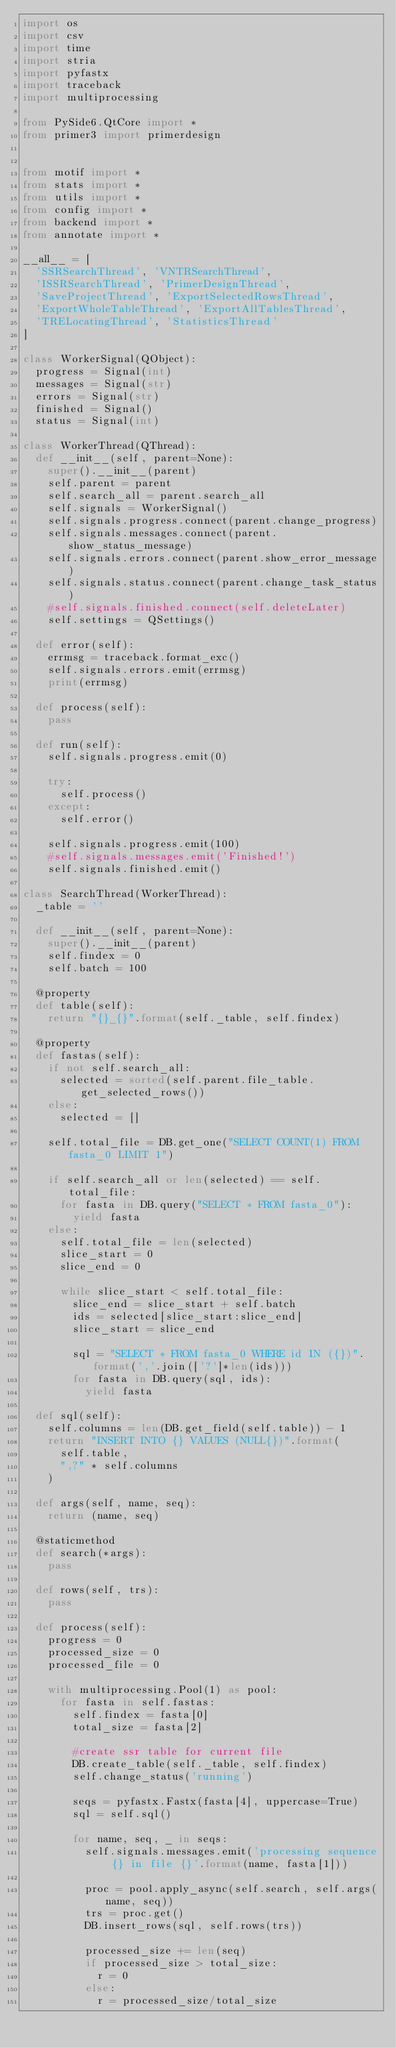Convert code to text. <code><loc_0><loc_0><loc_500><loc_500><_Python_>import os
import csv
import time
import stria
import pyfastx
import traceback
import multiprocessing

from PySide6.QtCore import *
from primer3 import primerdesign


from motif import *
from stats import *
from utils import *
from config import *
from backend import *
from annotate import *

__all__ = [
	'SSRSearchThread', 'VNTRSearchThread',
	'ISSRSearchThread', 'PrimerDesignThread',
	'SaveProjectThread', 'ExportSelectedRowsThread',
	'ExportWholeTableThread', 'ExportAllTablesThread',
	'TRELocatingThread', 'StatisticsThread'
]

class WorkerSignal(QObject):
	progress = Signal(int)
	messages = Signal(str)
	errors = Signal(str)
	finished = Signal()
	status = Signal(int)

class WorkerThread(QThread):
	def __init__(self, parent=None):
		super().__init__(parent)
		self.parent = parent
		self.search_all = parent.search_all
		self.signals = WorkerSignal()
		self.signals.progress.connect(parent.change_progress)
		self.signals.messages.connect(parent.show_status_message)
		self.signals.errors.connect(parent.show_error_message)
		self.signals.status.connect(parent.change_task_status)
		#self.signals.finished.connect(self.deleteLater)
		self.settings = QSettings()

	def error(self):
		errmsg = traceback.format_exc()
		self.signals.errors.emit(errmsg)
		print(errmsg)

	def process(self):
		pass

	def run(self):
		self.signals.progress.emit(0)

		try:
			self.process()
		except:
			self.error()

		self.signals.progress.emit(100)
		#self.signals.messages.emit('Finished!')
		self.signals.finished.emit()

class SearchThread(WorkerThread):
	_table = ''

	def __init__(self, parent=None):
		super().__init__(parent)
		self.findex = 0
		self.batch = 100

	@property
	def table(self):
		return "{}_{}".format(self._table, self.findex)

	@property
	def fastas(self):
		if not self.search_all:
			selected = sorted(self.parent.file_table.get_selected_rows())
		else:
			selected = []

		self.total_file = DB.get_one("SELECT COUNT(1) FROM fasta_0 LIMIT 1")
		
		if self.search_all or len(selected) == self.total_file:
			for fasta in DB.query("SELECT * FROM fasta_0"):
				yield fasta
		else:
			self.total_file = len(selected)
			slice_start = 0
			slice_end = 0
			
			while slice_start < self.total_file:
				slice_end = slice_start + self.batch
				ids = selected[slice_start:slice_end]
				slice_start = slice_end

				sql = "SELECT * FROM fasta_0 WHERE id IN ({})".format(','.join(['?']*len(ids)))
				for fasta in DB.query(sql, ids):
					yield fasta

	def sql(self):
		self.columns = len(DB.get_field(self.table)) - 1
		return "INSERT INTO {} VALUES (NULL{})".format(
			self.table,
			",?" * self.columns
		)

	def args(self, name, seq):
		return (name, seq)

	@staticmethod
	def search(*args):
		pass

	def rows(self, trs):
		pass

	def process(self):
		progress = 0
		processed_size = 0
		processed_file = 0

		with multiprocessing.Pool(1) as pool:
			for fasta in self.fastas:
				self.findex = fasta[0]
				total_size = fasta[2]

				#create ssr table for current file
				DB.create_table(self._table, self.findex)
				self.change_status('running')

				seqs = pyfastx.Fastx(fasta[4], uppercase=True)
				sql = self.sql()

				for name, seq, _ in seqs:
					self.signals.messages.emit('processing sequence {} in file {}'.format(name, fasta[1]))

					proc = pool.apply_async(self.search, self.args(name, seq))
					trs = proc.get()
					DB.insert_rows(sql, self.rows(trs))

					processed_size += len(seq)
					if processed_size > total_size:
						r = 0
					else:
						r = processed_size/total_size</code> 